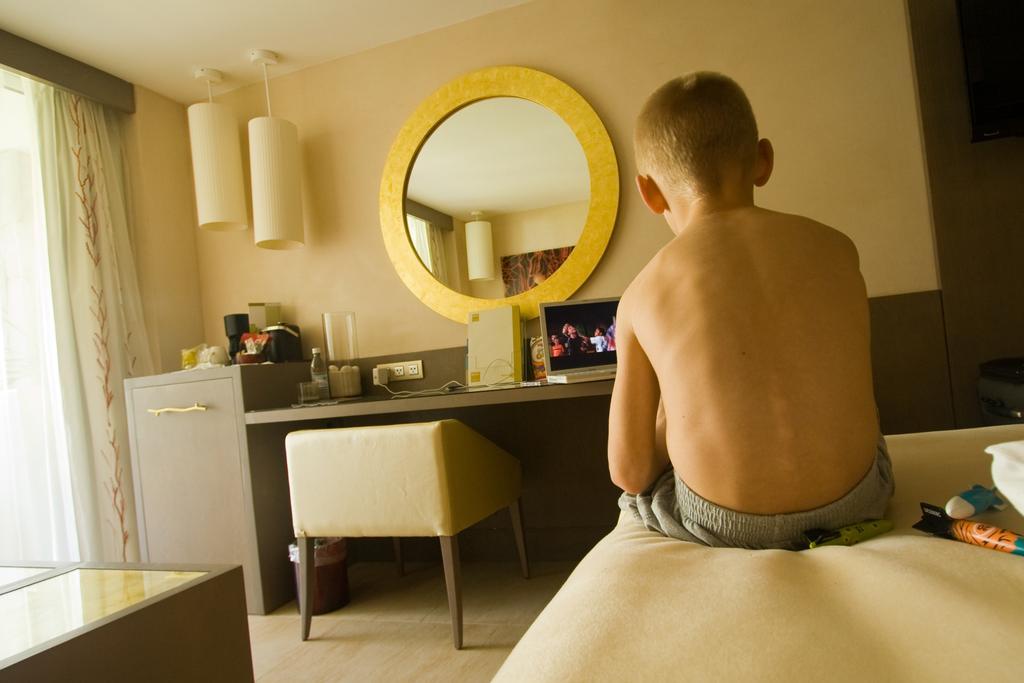Could you give a brief overview of what you see in this image? In this image I can see there is a boy sitting on the bed and there are few objects placed on the right side. There is a table, chair, there is a laptop and a few other objects placed on the table. There are two lights and a mirror attached to the wall and there is a window with a curtain at left side. 